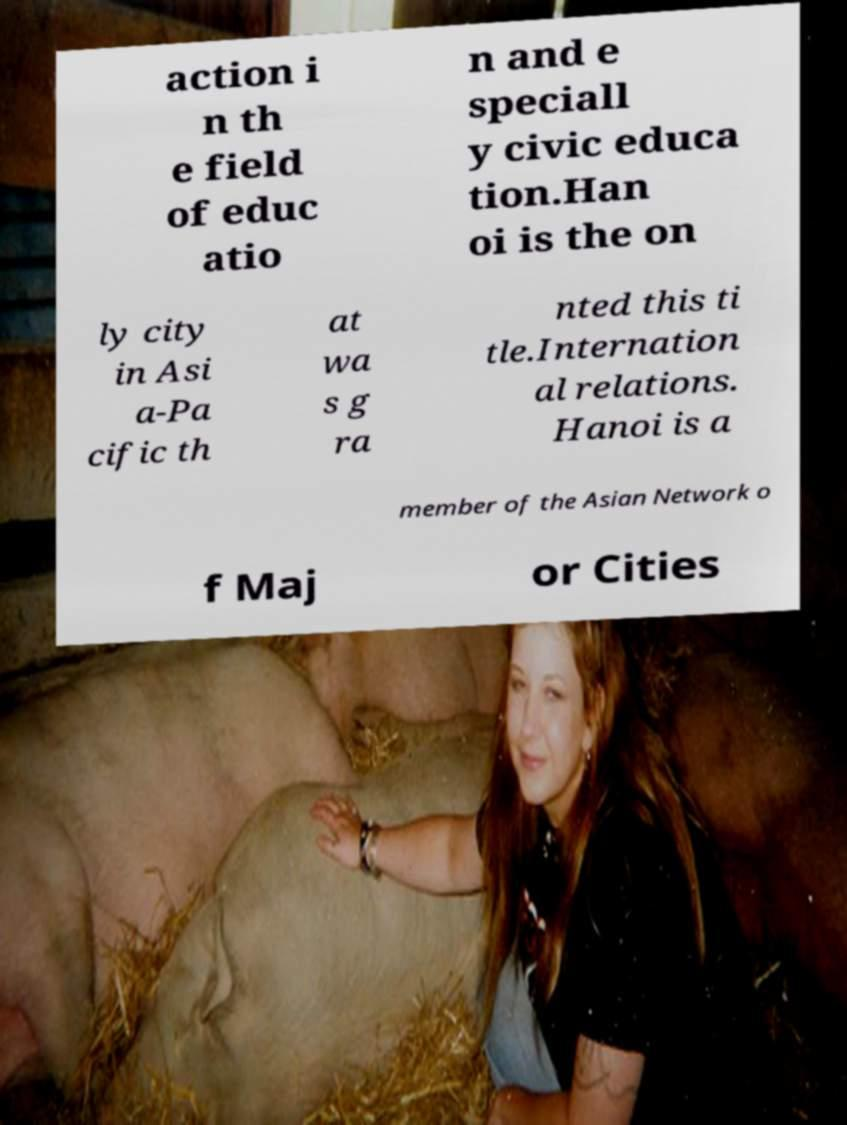There's text embedded in this image that I need extracted. Can you transcribe it verbatim? action i n th e field of educ atio n and e speciall y civic educa tion.Han oi is the on ly city in Asi a-Pa cific th at wa s g ra nted this ti tle.Internation al relations. Hanoi is a member of the Asian Network o f Maj or Cities 